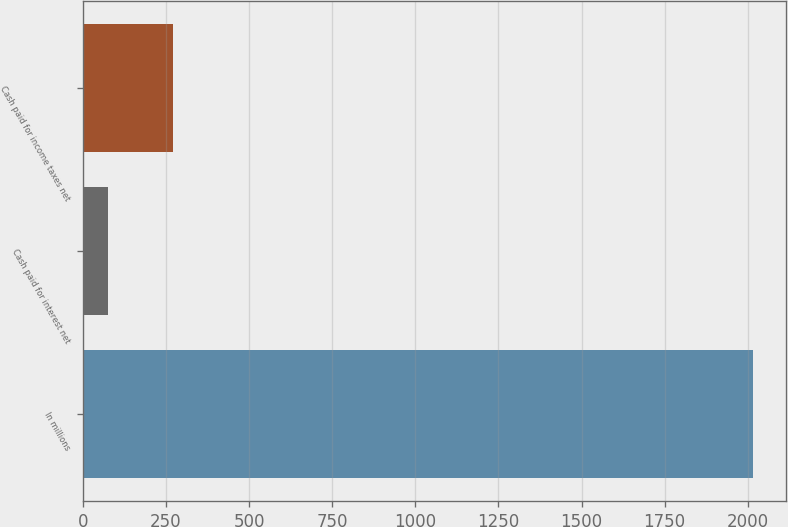<chart> <loc_0><loc_0><loc_500><loc_500><bar_chart><fcel>In millions<fcel>Cash paid for interest net<fcel>Cash paid for income taxes net<nl><fcel>2015<fcel>76.9<fcel>270.71<nl></chart> 